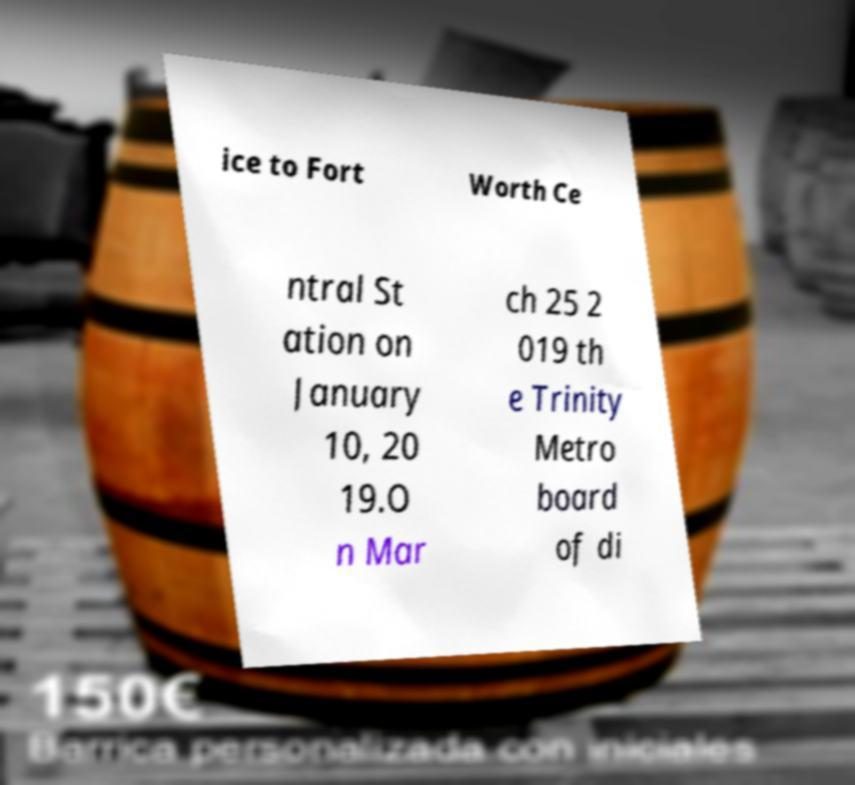Can you read and provide the text displayed in the image?This photo seems to have some interesting text. Can you extract and type it out for me? ice to Fort Worth Ce ntral St ation on January 10, 20 19.O n Mar ch 25 2 019 th e Trinity Metro board of di 